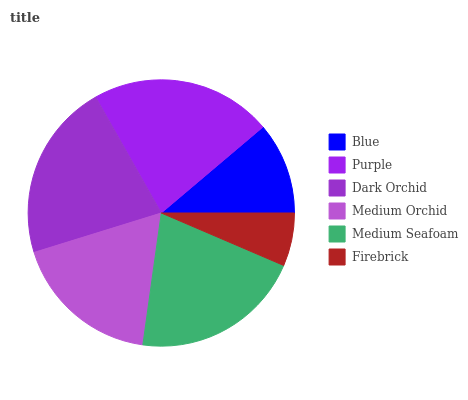Is Firebrick the minimum?
Answer yes or no. Yes. Is Purple the maximum?
Answer yes or no. Yes. Is Dark Orchid the minimum?
Answer yes or no. No. Is Dark Orchid the maximum?
Answer yes or no. No. Is Purple greater than Dark Orchid?
Answer yes or no. Yes. Is Dark Orchid less than Purple?
Answer yes or no. Yes. Is Dark Orchid greater than Purple?
Answer yes or no. No. Is Purple less than Dark Orchid?
Answer yes or no. No. Is Medium Seafoam the high median?
Answer yes or no. Yes. Is Medium Orchid the low median?
Answer yes or no. Yes. Is Medium Orchid the high median?
Answer yes or no. No. Is Medium Seafoam the low median?
Answer yes or no. No. 